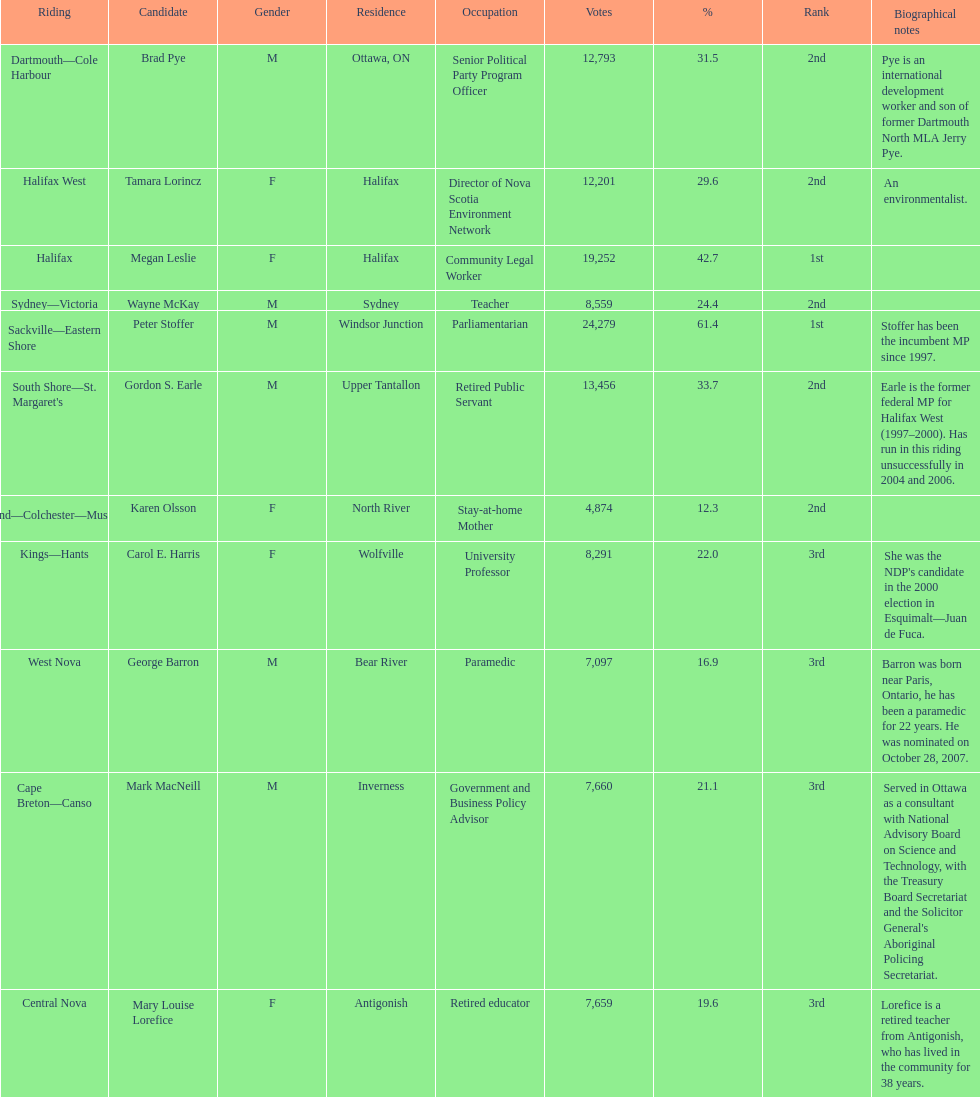How many candidates had more votes than tamara lorincz? 4. 